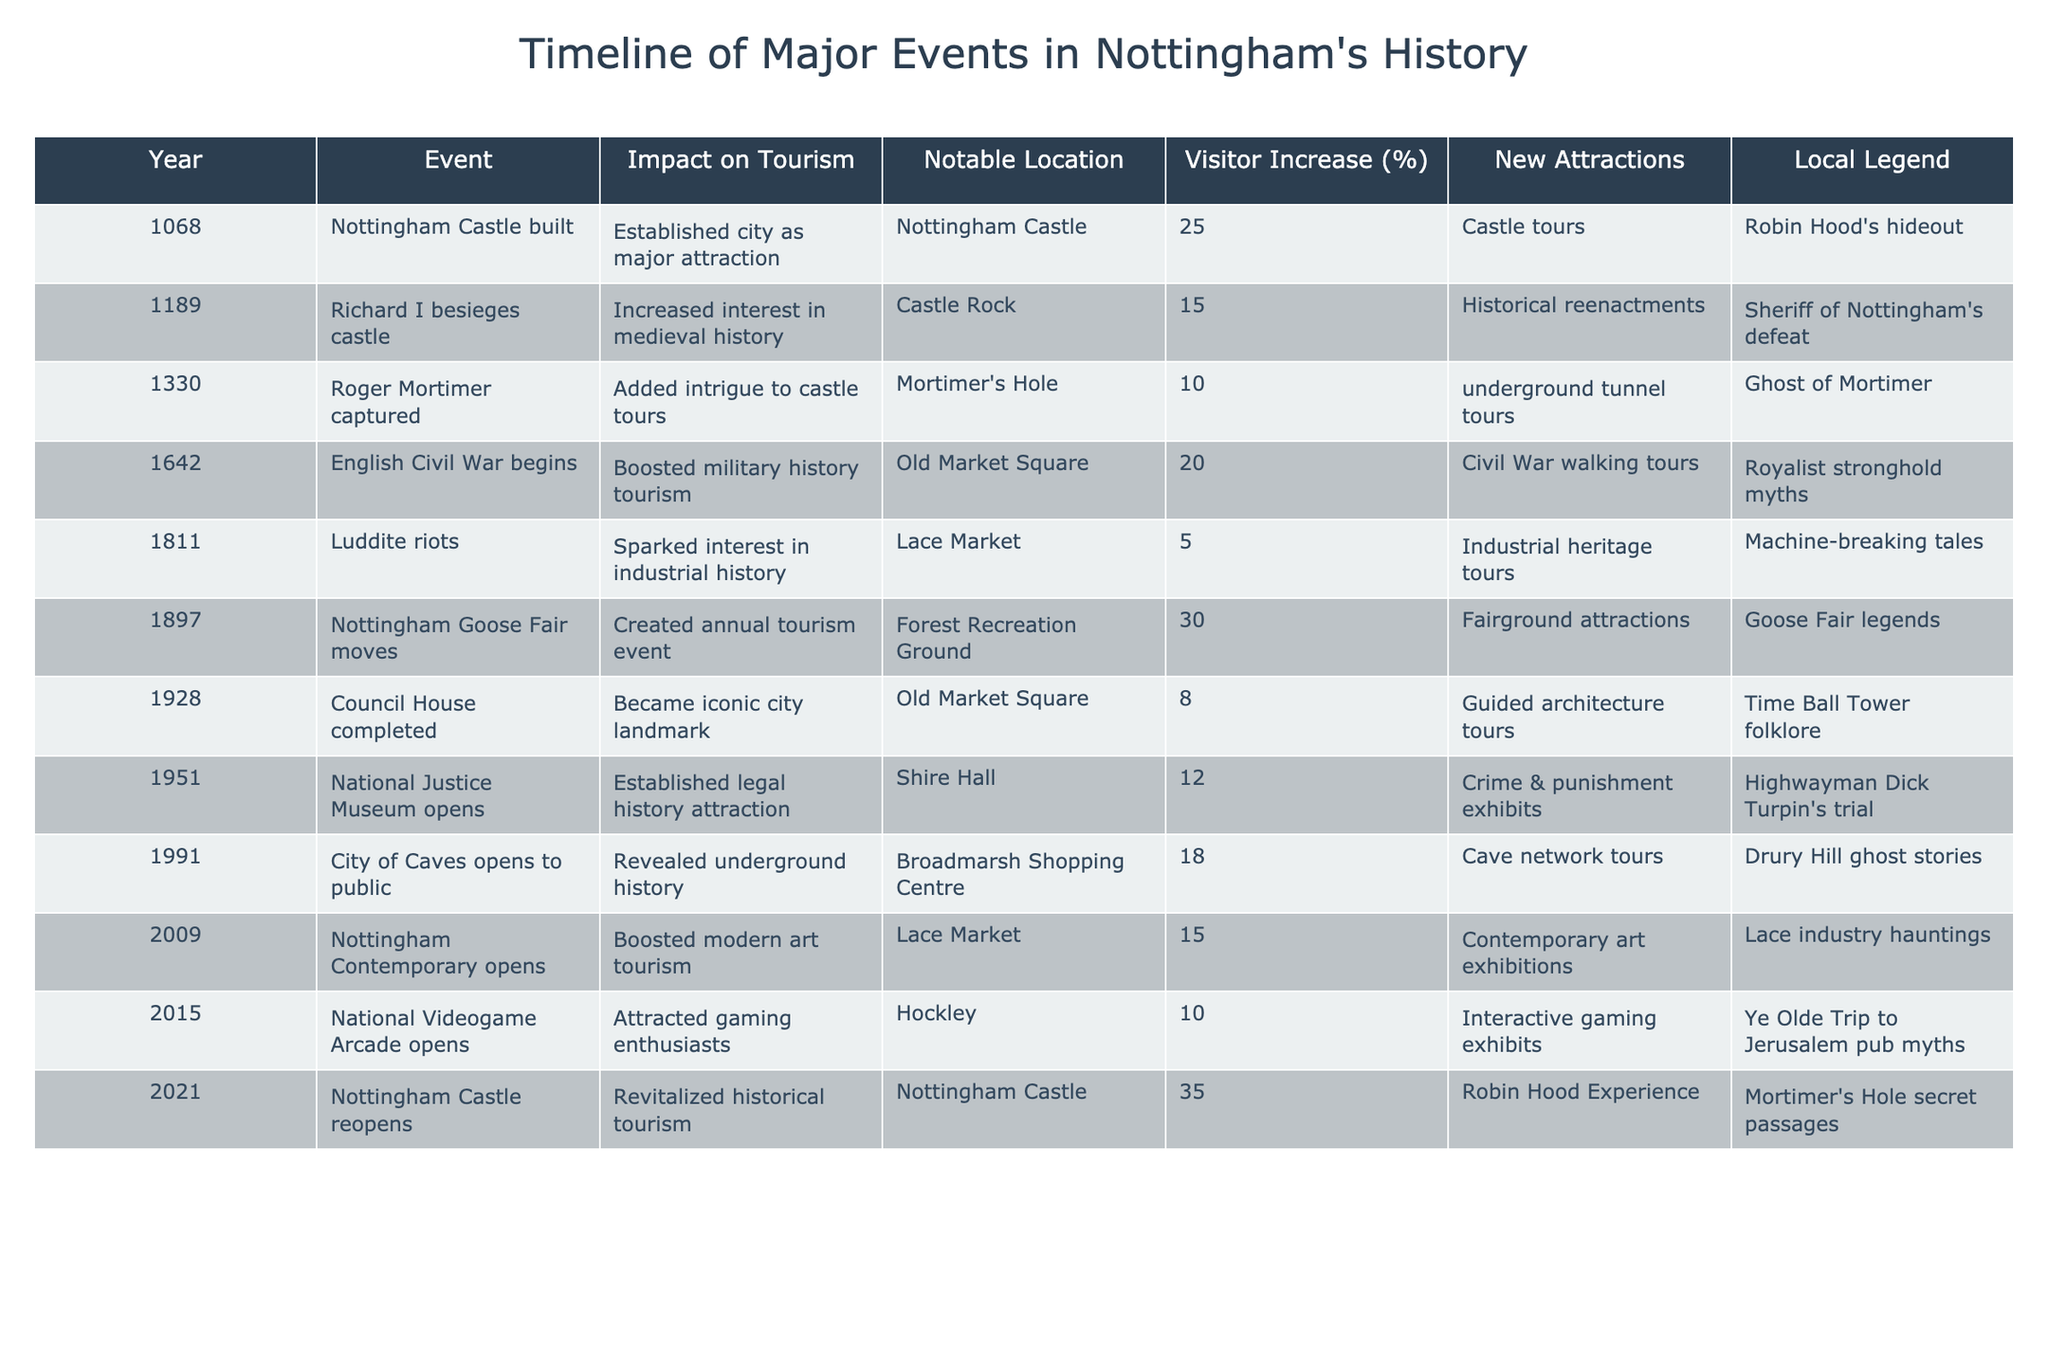What year did Nottingham Castle reopen? The table indicates that Nottingham Castle reopened in the year 2021.
Answer: 2021 What event led to a 35% increase in visitors? The reopening of Nottingham Castle in 2021 resulted in a 35% increase in visitors.
Answer: Nottingham Castle reopening Which locations had attractions added after 2000? The locations are Broadmarsh Shopping Centre (City of Caves in 1991), Lace Market (Nottingham Contemporary in 2009), Hockley (National Videogame Arcade in 2015), and Nottingham Castle (Robin Hood Experience in 2021).
Answer: Broadmarsh Shopping Centre, Lace Market, Hockley, Nottingham Castle What is the average visitor increase percentage from 1897 to 2021? The visitor increase percentages from that range are 30, 8, 12, 18, 15, and 35. Adding these gives 118, and dividing by 6 results in an average of 19.67%.
Answer: 19.67% Did the English Civil War boost tourism in Nottingham? Yes, it did; the event led to a 20% increase in visits due to military history tourism.
Answer: Yes Which event had the least impact on tourism in terms of visitor increase? The Luddite riots in 1811 had the least impact, with only a 5% increase in tourism.
Answer: 5% What notable local legend is associated with the reopening of Nottingham Castle? The reopening of Nottingham Castle is associated with the local legend of Mortimer's Hole secret passages.
Answer: Mortimer's Hole secret passages Which year saw the establishment of the National Justice Museum? The National Justice Museum opened in the year 1951.
Answer: 1951 Calculate the total visitor increase percentage across all recorded events. Adding up all the visitor increases: 25 + 15 + 10 + 20 + 5 + 30 + 8 + 12 + 18 + 15 + 10 + 35 =  288.
Answer: 288 What was the impact on tourism after the Luddite riots? The Luddite riots resulted in a 5% increase in tourism, showing only a minimal impact.
Answer: 5% 